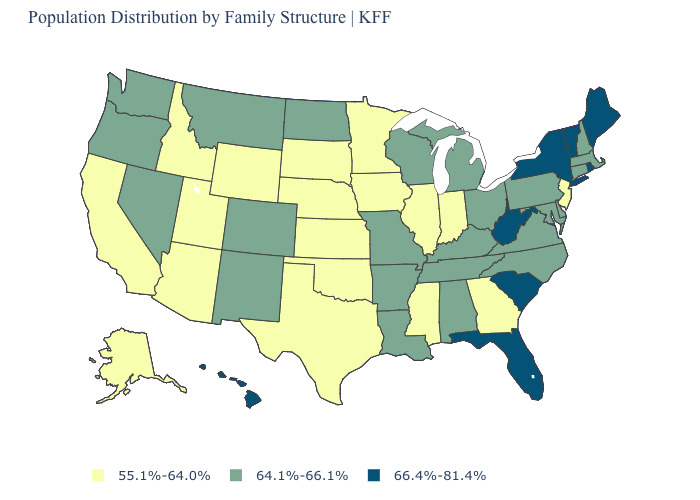What is the value of Kansas?
Short answer required. 55.1%-64.0%. How many symbols are there in the legend?
Keep it brief. 3. What is the value of South Carolina?
Keep it brief. 66.4%-81.4%. What is the highest value in the South ?
Write a very short answer. 66.4%-81.4%. What is the value of New York?
Be succinct. 66.4%-81.4%. Among the states that border Vermont , which have the highest value?
Write a very short answer. New York. Does Louisiana have the lowest value in the USA?
Give a very brief answer. No. What is the lowest value in states that border California?
Write a very short answer. 55.1%-64.0%. What is the highest value in the USA?
Short answer required. 66.4%-81.4%. Name the states that have a value in the range 64.1%-66.1%?
Short answer required. Alabama, Arkansas, Colorado, Connecticut, Delaware, Kentucky, Louisiana, Maryland, Massachusetts, Michigan, Missouri, Montana, Nevada, New Hampshire, New Mexico, North Carolina, North Dakota, Ohio, Oregon, Pennsylvania, Tennessee, Virginia, Washington, Wisconsin. Name the states that have a value in the range 64.1%-66.1%?
Quick response, please. Alabama, Arkansas, Colorado, Connecticut, Delaware, Kentucky, Louisiana, Maryland, Massachusetts, Michigan, Missouri, Montana, Nevada, New Hampshire, New Mexico, North Carolina, North Dakota, Ohio, Oregon, Pennsylvania, Tennessee, Virginia, Washington, Wisconsin. What is the value of New York?
Write a very short answer. 66.4%-81.4%. Name the states that have a value in the range 66.4%-81.4%?
Write a very short answer. Florida, Hawaii, Maine, New York, Rhode Island, South Carolina, Vermont, West Virginia. Does New Mexico have a higher value than Maryland?
Keep it brief. No. 